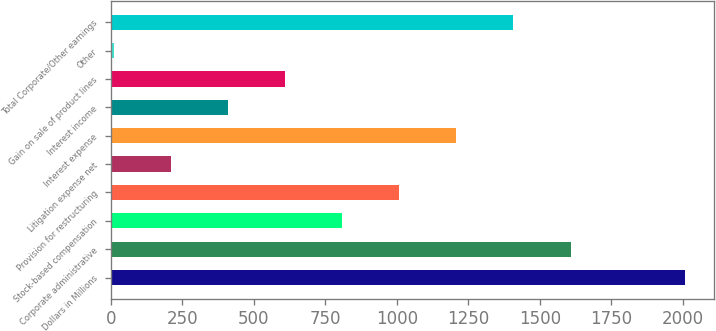Convert chart to OTSL. <chart><loc_0><loc_0><loc_500><loc_500><bar_chart><fcel>Dollars in Millions<fcel>Corporate administrative<fcel>Stock-based compensation<fcel>Provision for restructuring<fcel>Litigation expense net<fcel>Interest expense<fcel>Interest income<fcel>Gain on sale of product lines<fcel>Other<fcel>Total Corporate/Other earnings<nl><fcel>2008<fcel>1608.2<fcel>808.6<fcel>1008.5<fcel>208.9<fcel>1208.4<fcel>408.8<fcel>608.7<fcel>9<fcel>1408.3<nl></chart> 